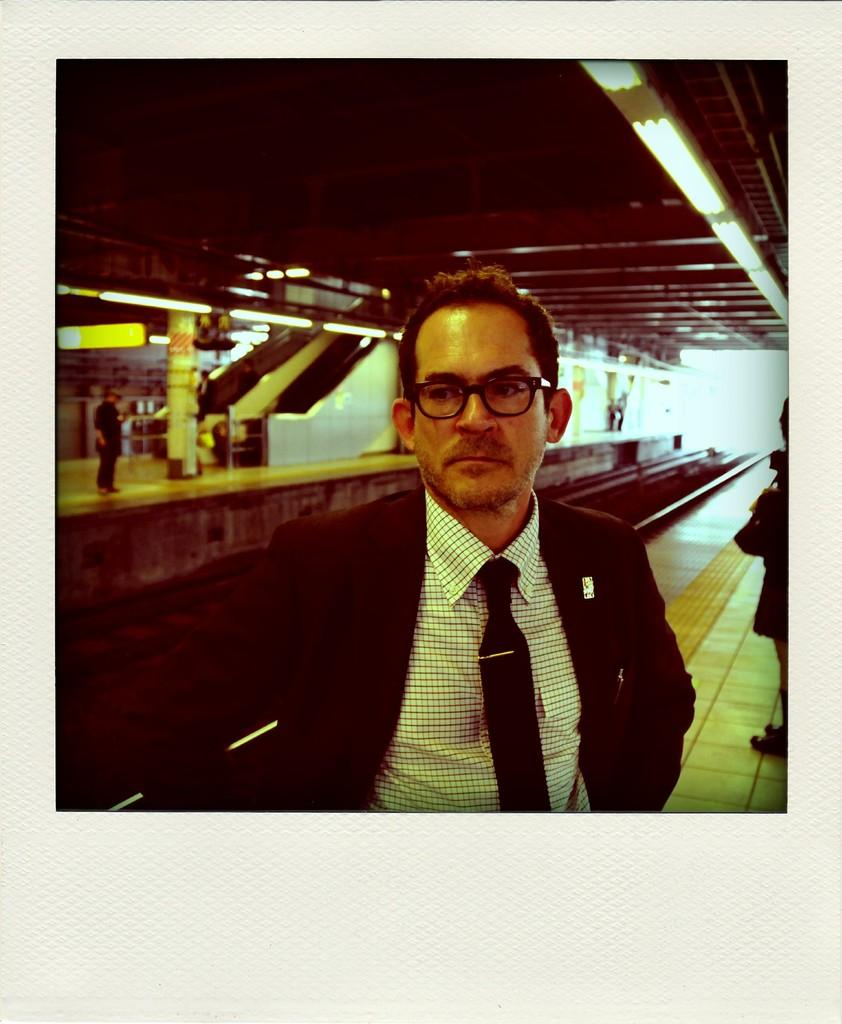What is the man in the image wearing on his upper body? The man is wearing a suit and a tie. What accessory is the man wearing on his face? The man is wearing spectacles. What can be seen in the background of the image? There are train tracks, people, pillars, and lights attached to the rooftop in the background. What type of pot is the man holding in the image? There is no pot present in the image; the man is not holding anything. Can you describe the man's body in the image? The provided facts do not mention any specific details about the man's body, so it cannot be described. 